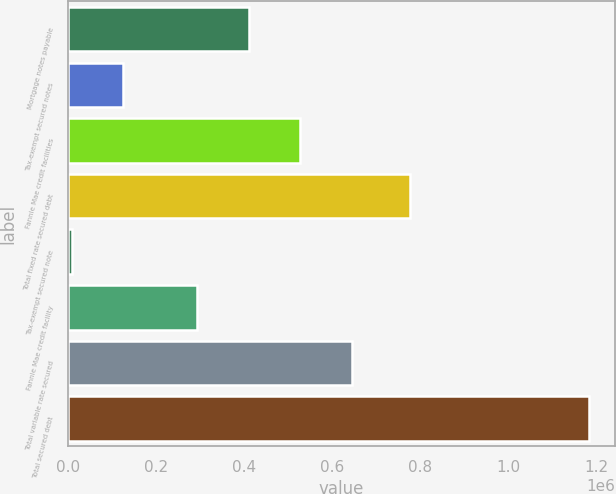Convert chart to OTSL. <chart><loc_0><loc_0><loc_500><loc_500><bar_chart><fcel>Mortgage notes payable<fcel>Tax-exempt secured notes<fcel>Fannie Mae credit facilities<fcel>Total fixed rate secured debt<fcel>Tax-exempt secured note<fcel>Fannie Mae credit facility<fcel>Total variable rate secured<fcel>Total secured debt<nl><fcel>409984<fcel>125285<fcel>527499<fcel>777591<fcel>7770<fcel>292469<fcel>645014<fcel>1.18292e+06<nl></chart> 